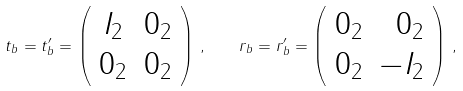Convert formula to latex. <formula><loc_0><loc_0><loc_500><loc_500>t _ { b } = t ^ { \prime } _ { b } = \left ( \begin{array} { c r } I _ { 2 } & 0 _ { 2 } \\ 0 _ { 2 } & 0 _ { 2 } \end{array} \right ) \, , \quad r _ { b } = r ^ { \prime } _ { b } = \left ( \begin{array} { c r } 0 _ { 2 } & 0 _ { 2 } \\ 0 _ { 2 } & - I _ { 2 } \end{array} \right ) \, ,</formula> 